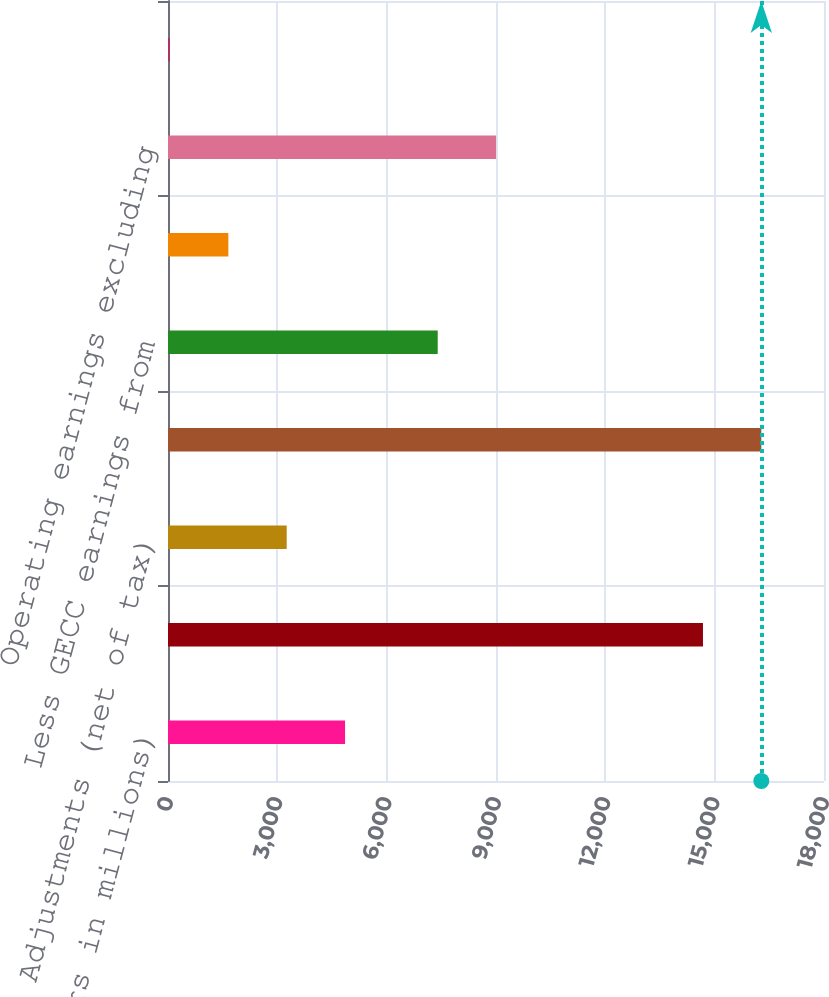<chart> <loc_0><loc_0><loc_500><loc_500><bar_chart><fcel>(Dollars in millions)<fcel>Earnings from continuing<fcel>Adjustments (net of tax)<fcel>Operating earnings<fcel>Less GECC earnings from<fcel>Less effect of GECC preferred<fcel>Operating earnings excluding<fcel>Industrial operating earnings<nl><fcel>4858<fcel>14679<fcel>3257<fcel>16280<fcel>7401<fcel>1656<fcel>9002<fcel>55<nl></chart> 